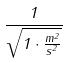<formula> <loc_0><loc_0><loc_500><loc_500>\frac { 1 } { \sqrt { 1 \cdot \frac { m ^ { 2 } } { s ^ { 2 } } } }</formula> 